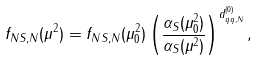Convert formula to latex. <formula><loc_0><loc_0><loc_500><loc_500>f _ { N S , N } ( \mu ^ { 2 } ) = f _ { N S , N } ( \mu _ { 0 } ^ { 2 } ) \left ( \frac { \alpha _ { S } ( \mu ^ { 2 } _ { 0 } ) } { \alpha _ { S } ( \mu ^ { 2 } ) } \right ) ^ { d _ { q q , N } ^ { ( 0 ) } } ,</formula> 